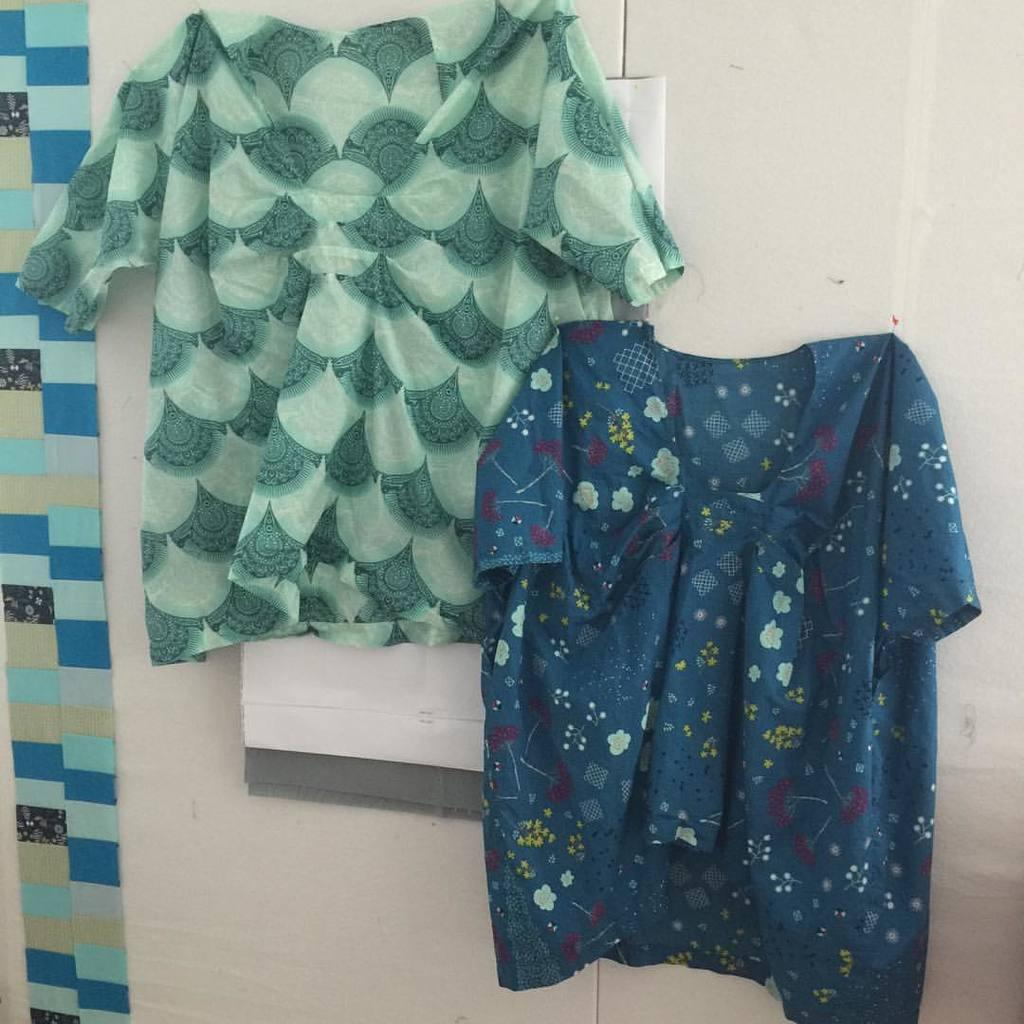What items are hung on the wall in the image? There are two shirts hung on the wall in the image. What can be seen on the left side of the image? There are color blocks on the left side of the image. What type of vegetable is growing on the wall next to the shirts? There is no vegetable growing on the wall next to the shirts in the image. 